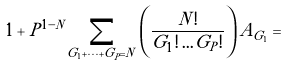<formula> <loc_0><loc_0><loc_500><loc_500>1 + P ^ { 1 - N } \sum _ { G _ { 1 } + \dots + G _ { P } = N } \left ( \frac { N ! } { G _ { 1 } ! \dots G _ { P } ! } \right ) A _ { G _ { 1 } } =</formula> 